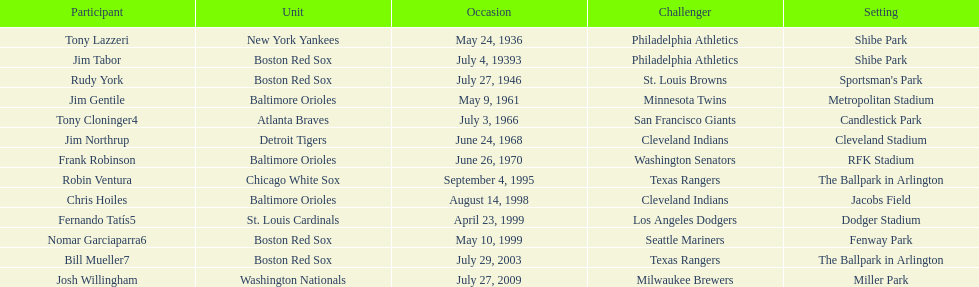What was the name of the player who accomplished this in 1999 but played for the boston red sox? Nomar Garciaparra. 